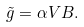<formula> <loc_0><loc_0><loc_500><loc_500>\tilde { g } = \alpha V B .</formula> 